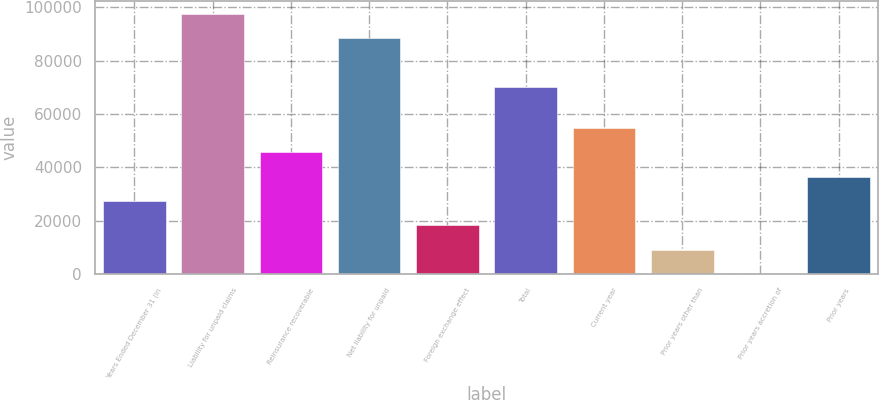Convert chart to OTSL. <chart><loc_0><loc_0><loc_500><loc_500><bar_chart><fcel>Years Ended December 31 (in<fcel>Liability for unpaid claims<fcel>Reinsurance recoverable<fcel>Net liability for unpaid<fcel>Foreign exchange effect<fcel>Total<fcel>Current year<fcel>Prior years other than<fcel>Prior years accretion of<fcel>Prior years<nl><fcel>27369.1<fcel>97492.1<fcel>45592.5<fcel>88380.4<fcel>18257.4<fcel>70157<fcel>54704.2<fcel>9145.7<fcel>34<fcel>36480.8<nl></chart> 